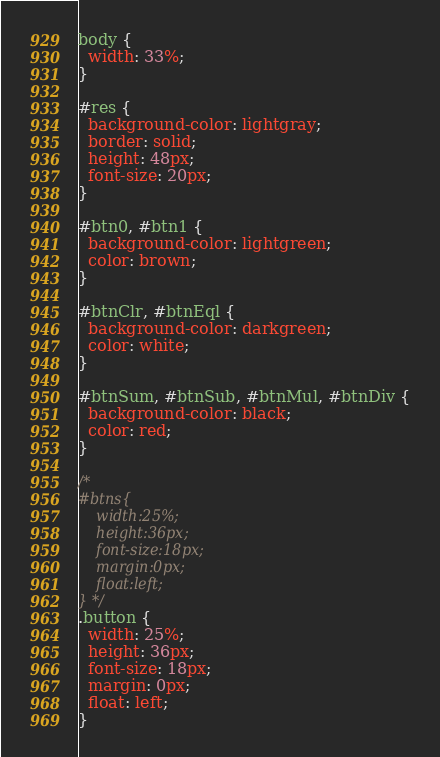<code> <loc_0><loc_0><loc_500><loc_500><_CSS_>body {
  width: 33%;
}

#res {
  background-color: lightgray;
  border: solid;
  height: 48px;
  font-size: 20px;
}

#btn0, #btn1 {
  background-color: lightgreen;
  color: brown;
}

#btnClr, #btnEql {
  background-color: darkgreen;
  color: white;
}

#btnSum, #btnSub, #btnMul, #btnDiv {
  background-color: black;
  color: red;
}

/*
#btns{
    width:25%;
    height:36px;
    font-size:18px;
    margin:0px;
    float:left;
} */
.button {
  width: 25%;
  height: 36px;
  font-size: 18px;
  margin: 0px;
  float: left;
}
</code> 